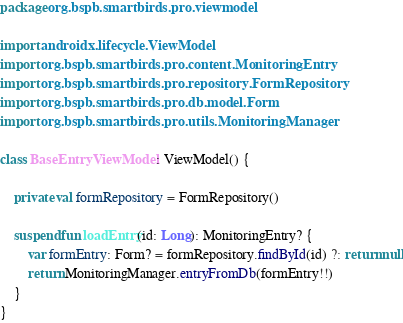Convert code to text. <code><loc_0><loc_0><loc_500><loc_500><_Kotlin_>package org.bspb.smartbirds.pro.viewmodel

import androidx.lifecycle.ViewModel
import org.bspb.smartbirds.pro.content.MonitoringEntry
import org.bspb.smartbirds.pro.repository.FormRepository
import org.bspb.smartbirds.pro.db.model.Form
import org.bspb.smartbirds.pro.utils.MonitoringManager

class BaseEntryViewModel : ViewModel() {

    private val formRepository = FormRepository()

    suspend fun loadEntry(id: Long): MonitoringEntry? {
        var formEntry: Form? = formRepository.findById(id) ?: return null
        return MonitoringManager.entryFromDb(formEntry!!)
    }
}</code> 